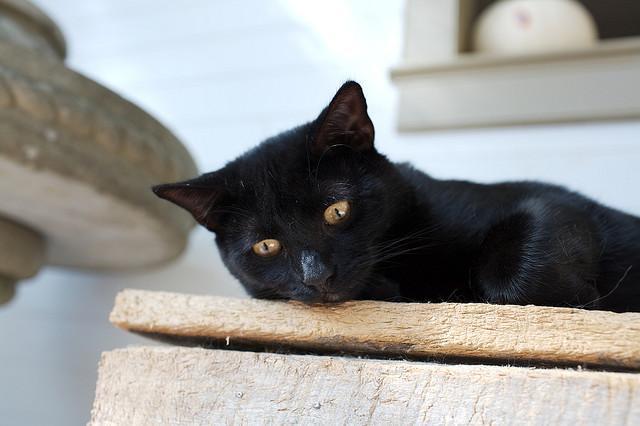How many paws is the cat laying on?
Give a very brief answer. 4. How many people are wearing a jacket in the picture?
Give a very brief answer. 0. 